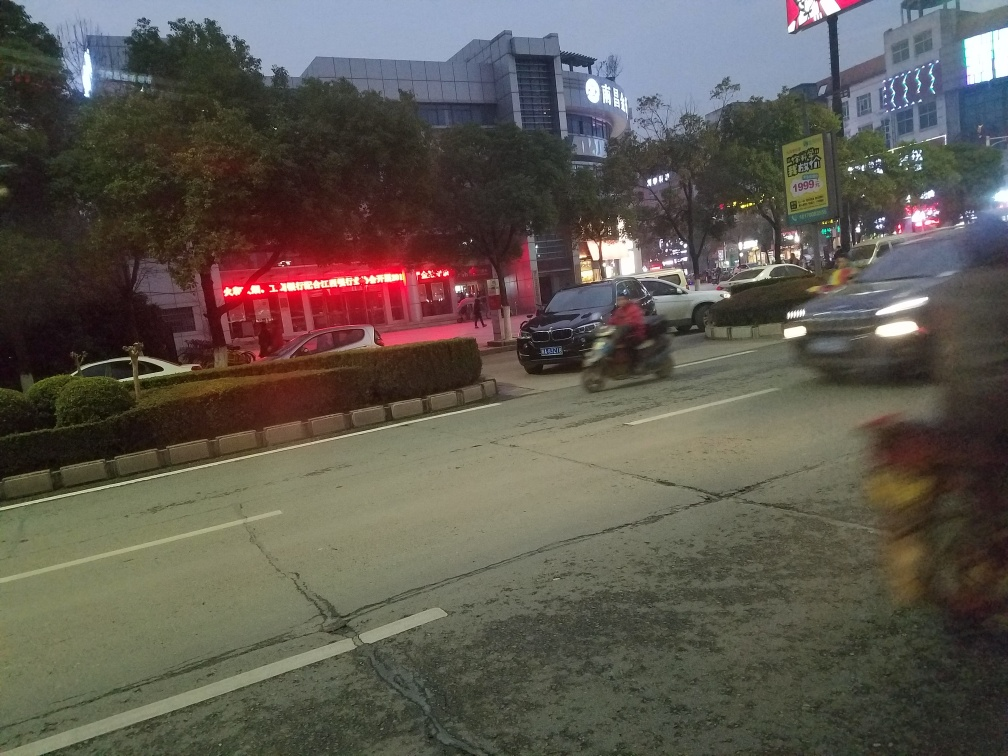What is the lighting condition of the scene, and how does it affect the image? The lighting condition in the scene is dim, which is likely due to the photo being taken during evening or twilight hours. This low light can result in a reduction of sharpness and visible details in the image, and can also affect the camera's ability to capture fast-moving subjects without blurring, as seen with the moving vehicles. How does the blur on moving objects affect the image's overall feel? The motion blur on the moving objects such as the motorcycle and car introduces a sense of speed and activity to the scene. It conveys the hustle and bustle of busy streets, potentially during rush hour. This movement juxtaposes with the stillness of the background elements, like the trees and buildings. 